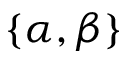<formula> <loc_0><loc_0><loc_500><loc_500>\{ \alpha , \beta \}</formula> 